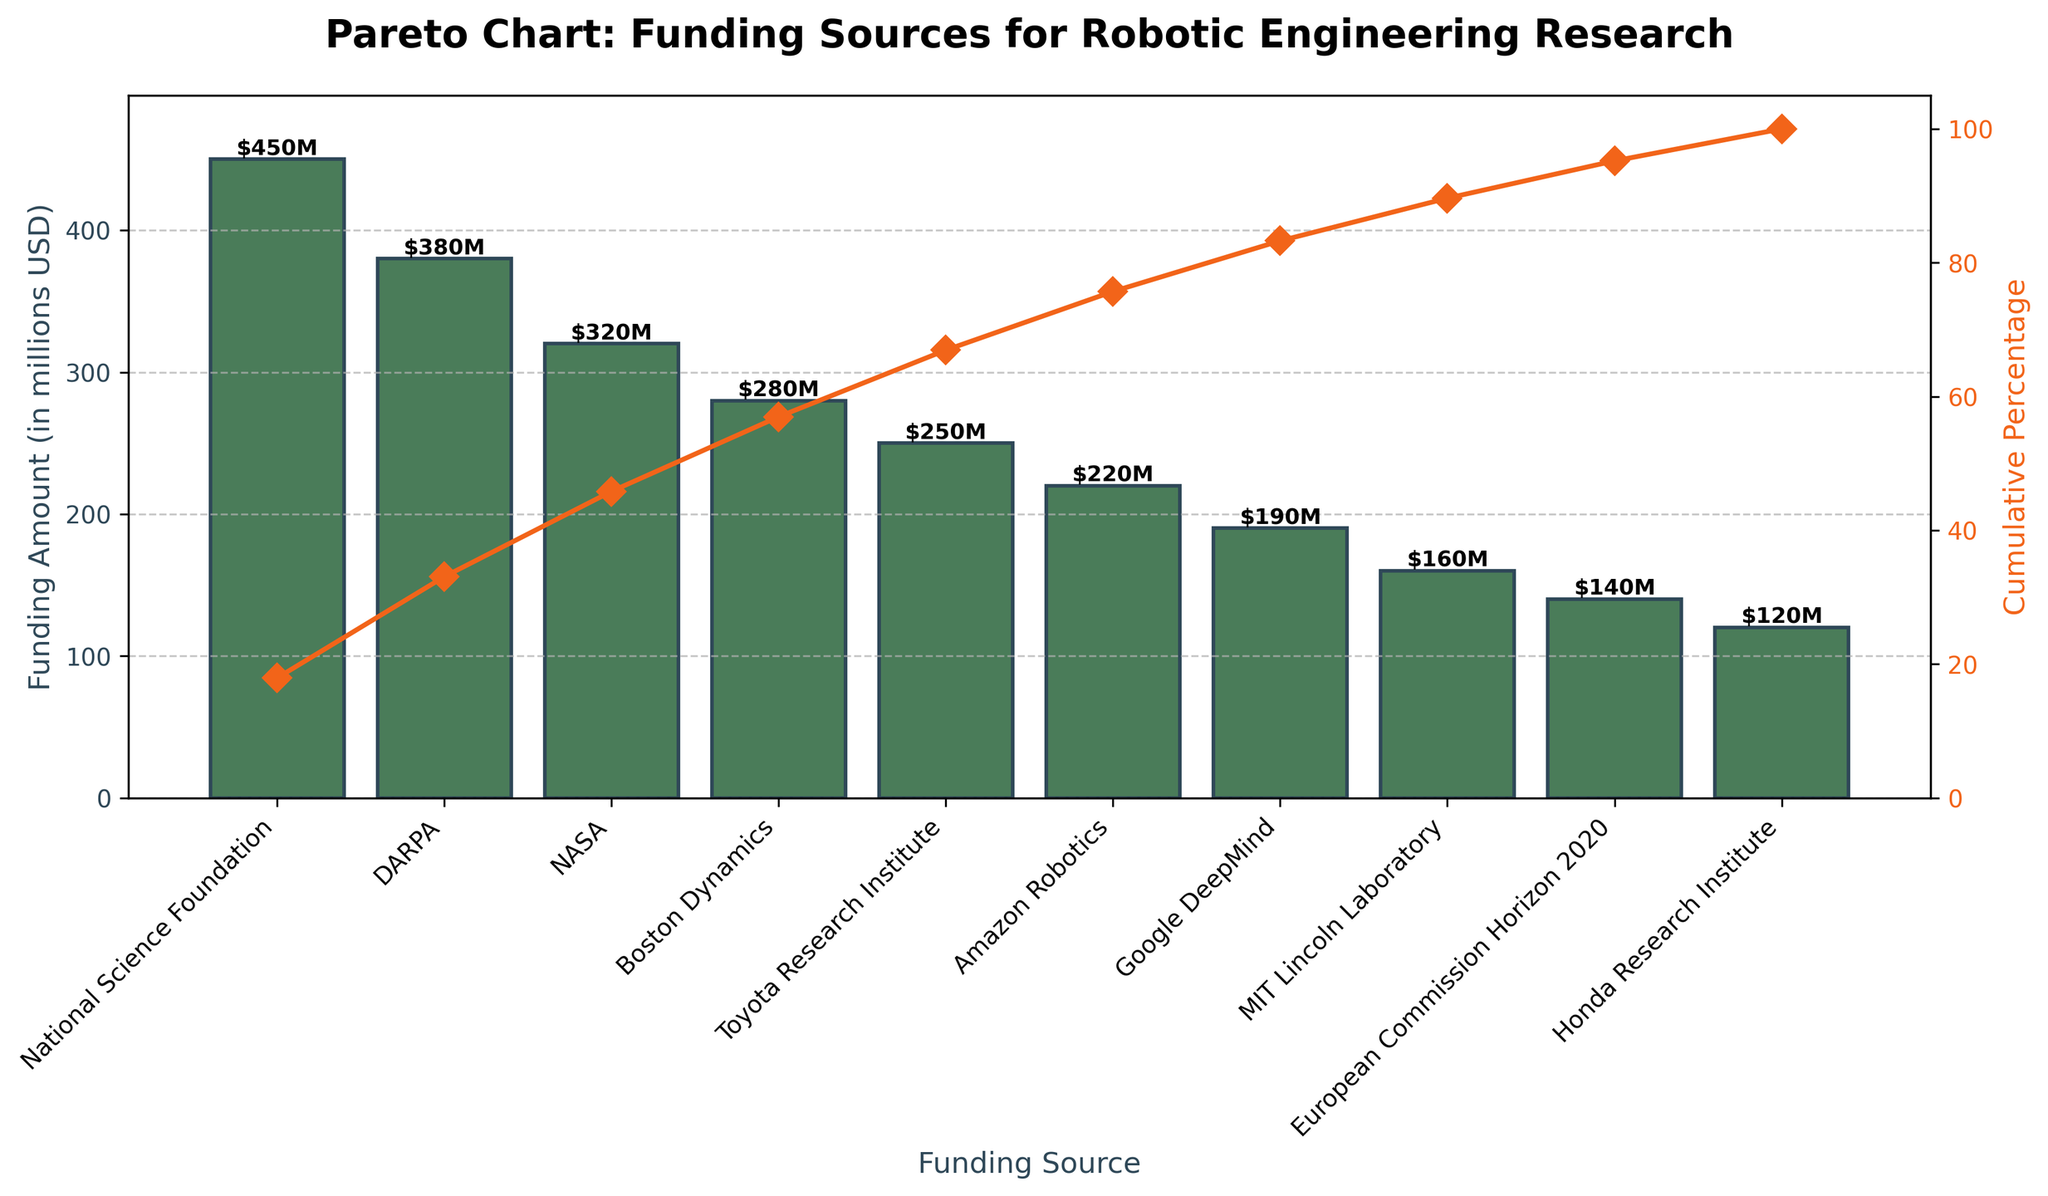What is the total funding amount from the National Science Foundation? The data shows that the National Science Foundation contributed 450 million USD. This value is displayed at the very first bar in the figure.
Answer: 450 million USD Which funding source contributed the least amount? By looking at the shortest bar, we can see that the Honda Research Institute contributed the least amount. This is confirmed by the label showing 120 million USD.
Answer: Honda Research Institute What is the cumulative percentage of total funding contributed by the top three sources? The cumulative contribution from the top three sources (National Science Foundation, DARPA, and NASA) reaches around 69%. This is calculated by summing their contributions (450 + 380 + 320) which gives 1150 million USD and then dividing by the total of 2510 million USD and multiplying by 100.
Answer: 69% How does the funding amount from Boston Dynamics compare to that from Toyota Research Institute? The bar for Boston Dynamics shows a contribution of 280 million USD, whereas the bar for Toyota Research Institute shows 250 million USD, indicating that Boston Dynamics contributed 30 million USD more.
Answer: 30 million USD more What percentage of the total funding does Amazon Robotics contribute? The bar representing Amazon Robotics shows a contribution of 220 million USD. To find the percentage, divide 220 million USD by the total funding 2510 million USD and multiply by 100. This calculation results in approximately 8.8%.
Answer: 8.8% Which funding source appears fourth on the chart and what is its contribution? The fourth bar in descending order represents Boston Dynamics, which contributed 280 million USD.
Answer: Boston Dynamics, 280 million USD What is the overall pattern between funding sources and their contributions? By analyzing the decreasing height of the bars from left to right, it is evident that the contributions decrease as we move from highly ranked funding sources to lower-ranked ones.
Answer: Contributions decrease from highly ranked to lower-ranked sources What is the cumulative percentage at the contribution from Google DeepMind? Google DeepMind is the 7th bar, and the cumulative percentage reaches around 81%. The cumulative percentage graph shows an increase to this value as Google DeepMind's contribution is added.
Answer: 81% Can you identify any major funding sources that collectively contribute more than half of the total funding? The cumulative percentage line reaches over 50% after the contributions from the National Science Foundation and DARPA, indicating these two sources jointly contribute more than half of the total funding.
Answer: National Science Foundation and DARPA If we are to remove Honda Research Institute's funding from the chart, how would that affect the total funding amount? Honda Research Institute's contribution is 120 million USD. Removing this would result in an updated total funding of 2510 - 120 = 2390 million USD.
Answer: 2390 million USD 